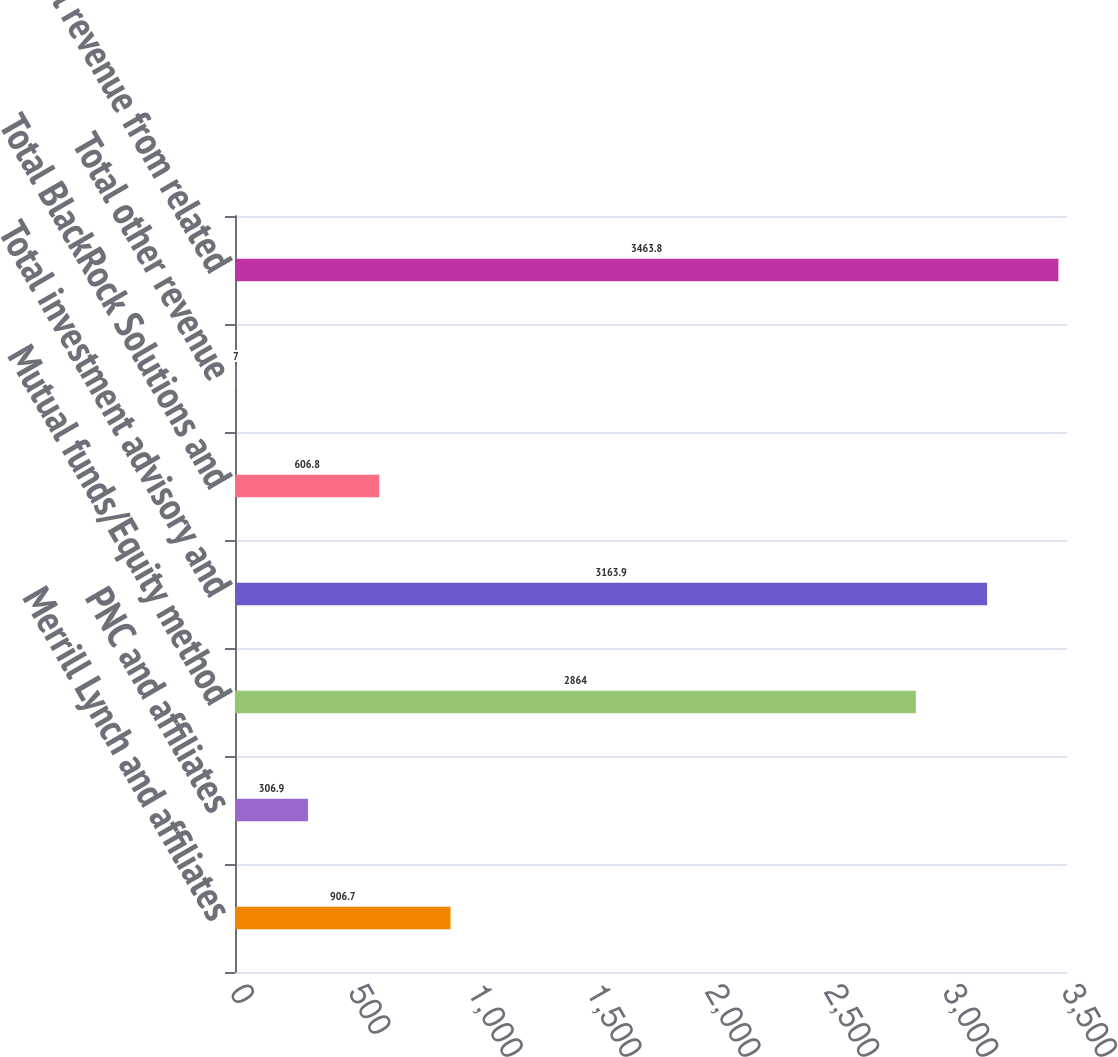Convert chart to OTSL. <chart><loc_0><loc_0><loc_500><loc_500><bar_chart><fcel>Merrill Lynch and affiliates<fcel>PNC and affiliates<fcel>Mutual funds/Equity method<fcel>Total investment advisory and<fcel>Total BlackRock Solutions and<fcel>Total other revenue<fcel>Total revenue from related<nl><fcel>906.7<fcel>306.9<fcel>2864<fcel>3163.9<fcel>606.8<fcel>7<fcel>3463.8<nl></chart> 